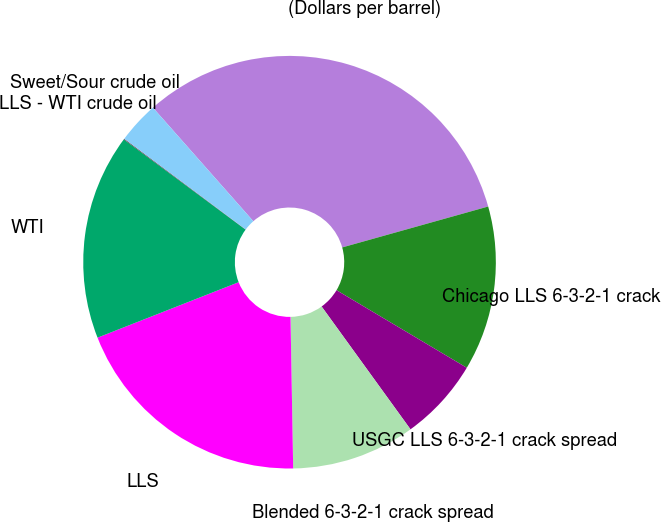Convert chart. <chart><loc_0><loc_0><loc_500><loc_500><pie_chart><fcel>(Dollars per barrel)<fcel>Chicago LLS 6-3-2-1 crack<fcel>USGC LLS 6-3-2-1 crack spread<fcel>Blended 6-3-2-1 crack spread<fcel>LLS<fcel>WTI<fcel>LLS - WTI crude oil<fcel>Sweet/Sour crude oil<nl><fcel>32.17%<fcel>12.9%<fcel>6.48%<fcel>9.69%<fcel>19.32%<fcel>16.11%<fcel>0.06%<fcel>3.27%<nl></chart> 